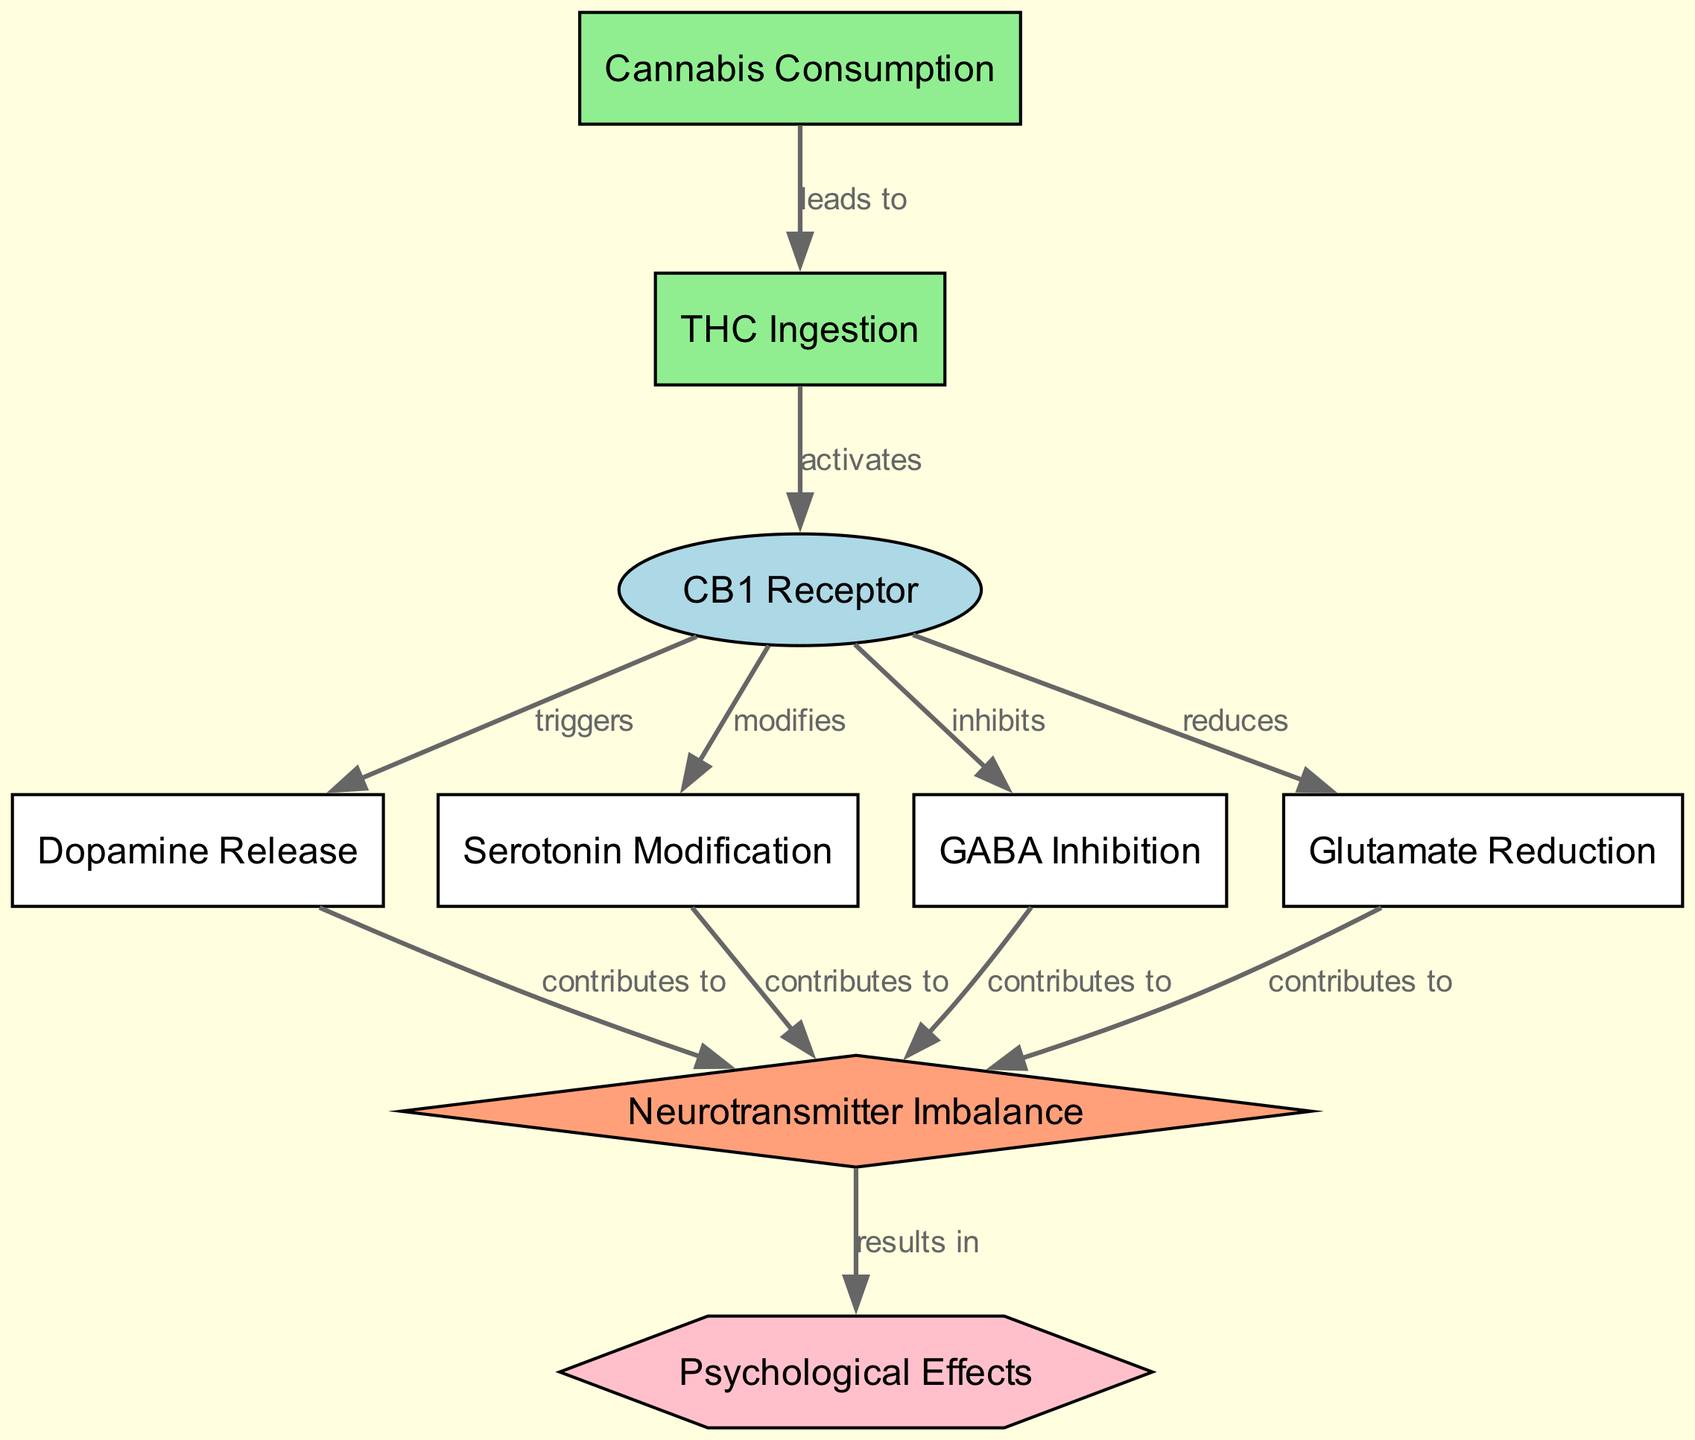What is the starting node in the diagram? The starting node is "Cannabis Consumption" as it is the first point of interaction leading to THC ingestion.
Answer: Cannabis Consumption How many edges are in the diagram? Counting the connections between the nodes, there are a total of 10 edges represented in the diagram.
Answer: 10 What does THC Ingestion activate? THC Ingestion activates the "CB1 Receptor," which is the next logical step in the flow of the diagram.
Answer: CB1 Receptor What effect does the CB1 Receptor have on Dopamine Release? The CB1 Receptor triggers Dopamine Release, indicating a direct impact on the dopamine system.
Answer: triggers What are the four contributors to Neurotransmitter Imbalance? The four contributors are Dopamine Release, Serotonin Modification, GABA Inhibition, and Glutamate Reduction, which are all listed as contributing factors to imbalance.
Answer: Dopamine Release, Serotonin Modification, GABA Inhibition, Glutamate Reduction How does Neurotransmitter Imbalance affect Psychological Effects? Neurotransmitter Imbalance results in Psychological Effects, indicating a direct consequence as depicted in the flow of the diagram.
Answer: results in What type of node is the "CB1 Receptor"? The "CB1 Receptor" is an ellipse, indicating it is categorized as a receptor in the diagram.
Answer: ellipse Which neurotransmitter is reduced by the CB1 Receptor? The CB1 Receptor reduces Glutamate, as shown by the direct relationship drawn in the diagram.
Answer: Glutamate Reduction What happens after Cannabis Consumption? After Cannabis Consumption, it leads to THC Ingestion, signifying the first connection in the flow of the diagram.
Answer: THC Ingestion How many psychological effects are shown as a result of neurotransmitter imbalance? The diagram illustrates that there is one outcome listed as "Psychological Effects" resulting from the neurotransmitter imbalance.
Answer: 1 